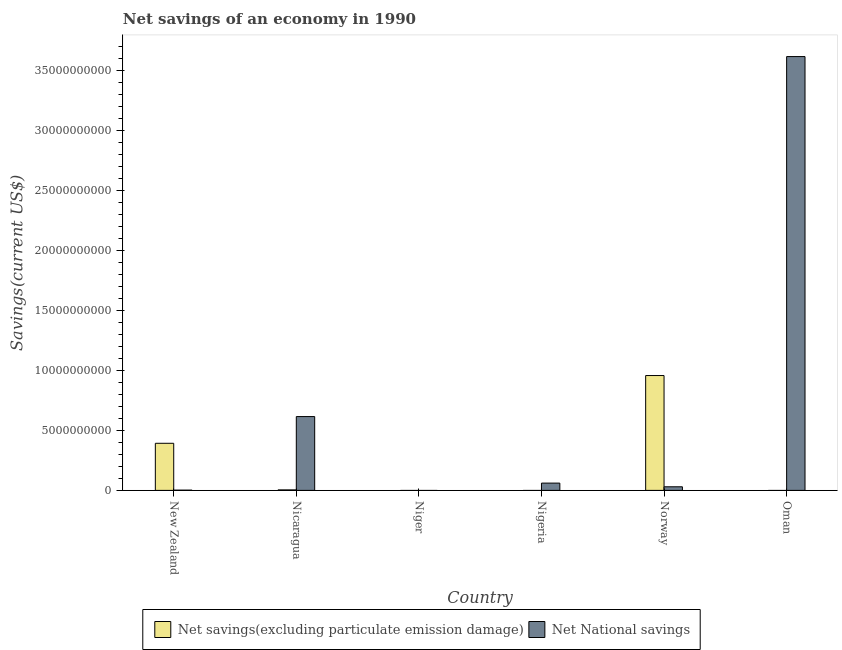Are the number of bars per tick equal to the number of legend labels?
Provide a succinct answer. No. Are the number of bars on each tick of the X-axis equal?
Keep it short and to the point. No. How many bars are there on the 2nd tick from the left?
Your answer should be compact. 2. How many bars are there on the 3rd tick from the right?
Your response must be concise. 1. What is the label of the 1st group of bars from the left?
Offer a very short reply. New Zealand. What is the net national savings in Niger?
Give a very brief answer. 0. Across all countries, what is the maximum net national savings?
Keep it short and to the point. 3.62e+1. What is the total net savings(excluding particulate emission damage) in the graph?
Offer a terse response. 1.35e+1. What is the difference between the net national savings in New Zealand and that in Oman?
Your answer should be compact. -3.62e+1. What is the difference between the net national savings in Oman and the net savings(excluding particulate emission damage) in Nigeria?
Offer a very short reply. 3.62e+1. What is the average net savings(excluding particulate emission damage) per country?
Your answer should be very brief. 2.26e+09. What is the difference between the net savings(excluding particulate emission damage) and net national savings in Norway?
Ensure brevity in your answer.  9.28e+09. What is the ratio of the net national savings in Norway to that in Oman?
Your answer should be compact. 0.01. What is the difference between the highest and the second highest net savings(excluding particulate emission damage)?
Give a very brief answer. 5.65e+09. What is the difference between the highest and the lowest net savings(excluding particulate emission damage)?
Provide a short and direct response. 9.58e+09. In how many countries, is the net savings(excluding particulate emission damage) greater than the average net savings(excluding particulate emission damage) taken over all countries?
Your answer should be very brief. 2. Is the sum of the net savings(excluding particulate emission damage) in New Zealand and Nicaragua greater than the maximum net national savings across all countries?
Provide a succinct answer. No. How many bars are there?
Give a very brief answer. 8. Are all the bars in the graph horizontal?
Your answer should be compact. No. How many countries are there in the graph?
Provide a succinct answer. 6. What is the difference between two consecutive major ticks on the Y-axis?
Provide a short and direct response. 5.00e+09. Where does the legend appear in the graph?
Provide a succinct answer. Bottom center. How are the legend labels stacked?
Your response must be concise. Horizontal. What is the title of the graph?
Make the answer very short. Net savings of an economy in 1990. What is the label or title of the Y-axis?
Your answer should be very brief. Savings(current US$). What is the Savings(current US$) of Net savings(excluding particulate emission damage) in New Zealand?
Your answer should be very brief. 3.93e+09. What is the Savings(current US$) in Net National savings in New Zealand?
Offer a terse response. 2.00e+07. What is the Savings(current US$) in Net savings(excluding particulate emission damage) in Nicaragua?
Provide a short and direct response. 4.16e+07. What is the Savings(current US$) in Net National savings in Nicaragua?
Offer a terse response. 6.15e+09. What is the Savings(current US$) in Net savings(excluding particulate emission damage) in Niger?
Your answer should be very brief. 0. What is the Savings(current US$) of Net National savings in Nigeria?
Provide a succinct answer. 6.08e+08. What is the Savings(current US$) in Net savings(excluding particulate emission damage) in Norway?
Ensure brevity in your answer.  9.58e+09. What is the Savings(current US$) in Net National savings in Norway?
Ensure brevity in your answer.  3.01e+08. What is the Savings(current US$) in Net savings(excluding particulate emission damage) in Oman?
Your answer should be compact. 0. What is the Savings(current US$) of Net National savings in Oman?
Your answer should be compact. 3.62e+1. Across all countries, what is the maximum Savings(current US$) of Net savings(excluding particulate emission damage)?
Your answer should be very brief. 9.58e+09. Across all countries, what is the maximum Savings(current US$) of Net National savings?
Ensure brevity in your answer.  3.62e+1. Across all countries, what is the minimum Savings(current US$) in Net savings(excluding particulate emission damage)?
Keep it short and to the point. 0. What is the total Savings(current US$) of Net savings(excluding particulate emission damage) in the graph?
Your response must be concise. 1.35e+1. What is the total Savings(current US$) in Net National savings in the graph?
Provide a short and direct response. 4.33e+1. What is the difference between the Savings(current US$) of Net savings(excluding particulate emission damage) in New Zealand and that in Nicaragua?
Provide a short and direct response. 3.89e+09. What is the difference between the Savings(current US$) of Net National savings in New Zealand and that in Nicaragua?
Ensure brevity in your answer.  -6.13e+09. What is the difference between the Savings(current US$) of Net National savings in New Zealand and that in Nigeria?
Make the answer very short. -5.88e+08. What is the difference between the Savings(current US$) of Net savings(excluding particulate emission damage) in New Zealand and that in Norway?
Your response must be concise. -5.65e+09. What is the difference between the Savings(current US$) of Net National savings in New Zealand and that in Norway?
Your answer should be compact. -2.81e+08. What is the difference between the Savings(current US$) of Net National savings in New Zealand and that in Oman?
Give a very brief answer. -3.62e+1. What is the difference between the Savings(current US$) of Net National savings in Nicaragua and that in Nigeria?
Keep it short and to the point. 5.55e+09. What is the difference between the Savings(current US$) in Net savings(excluding particulate emission damage) in Nicaragua and that in Norway?
Keep it short and to the point. -9.53e+09. What is the difference between the Savings(current US$) in Net National savings in Nicaragua and that in Norway?
Your response must be concise. 5.85e+09. What is the difference between the Savings(current US$) in Net National savings in Nicaragua and that in Oman?
Your answer should be very brief. -3.00e+1. What is the difference between the Savings(current US$) of Net National savings in Nigeria and that in Norway?
Your answer should be compact. 3.08e+08. What is the difference between the Savings(current US$) in Net National savings in Nigeria and that in Oman?
Provide a succinct answer. -3.56e+1. What is the difference between the Savings(current US$) in Net National savings in Norway and that in Oman?
Your answer should be very brief. -3.59e+1. What is the difference between the Savings(current US$) of Net savings(excluding particulate emission damage) in New Zealand and the Savings(current US$) of Net National savings in Nicaragua?
Your response must be concise. -2.23e+09. What is the difference between the Savings(current US$) of Net savings(excluding particulate emission damage) in New Zealand and the Savings(current US$) of Net National savings in Nigeria?
Keep it short and to the point. 3.32e+09. What is the difference between the Savings(current US$) in Net savings(excluding particulate emission damage) in New Zealand and the Savings(current US$) in Net National savings in Norway?
Offer a terse response. 3.63e+09. What is the difference between the Savings(current US$) of Net savings(excluding particulate emission damage) in New Zealand and the Savings(current US$) of Net National savings in Oman?
Ensure brevity in your answer.  -3.22e+1. What is the difference between the Savings(current US$) in Net savings(excluding particulate emission damage) in Nicaragua and the Savings(current US$) in Net National savings in Nigeria?
Your answer should be compact. -5.67e+08. What is the difference between the Savings(current US$) of Net savings(excluding particulate emission damage) in Nicaragua and the Savings(current US$) of Net National savings in Norway?
Your answer should be compact. -2.59e+08. What is the difference between the Savings(current US$) of Net savings(excluding particulate emission damage) in Nicaragua and the Savings(current US$) of Net National savings in Oman?
Provide a succinct answer. -3.61e+1. What is the difference between the Savings(current US$) of Net savings(excluding particulate emission damage) in Norway and the Savings(current US$) of Net National savings in Oman?
Provide a succinct answer. -2.66e+1. What is the average Savings(current US$) of Net savings(excluding particulate emission damage) per country?
Your response must be concise. 2.26e+09. What is the average Savings(current US$) in Net National savings per country?
Make the answer very short. 7.21e+09. What is the difference between the Savings(current US$) of Net savings(excluding particulate emission damage) and Savings(current US$) of Net National savings in New Zealand?
Provide a short and direct response. 3.91e+09. What is the difference between the Savings(current US$) of Net savings(excluding particulate emission damage) and Savings(current US$) of Net National savings in Nicaragua?
Your response must be concise. -6.11e+09. What is the difference between the Savings(current US$) of Net savings(excluding particulate emission damage) and Savings(current US$) of Net National savings in Norway?
Make the answer very short. 9.28e+09. What is the ratio of the Savings(current US$) of Net savings(excluding particulate emission damage) in New Zealand to that in Nicaragua?
Offer a terse response. 94.5. What is the ratio of the Savings(current US$) of Net National savings in New Zealand to that in Nicaragua?
Your answer should be compact. 0. What is the ratio of the Savings(current US$) in Net National savings in New Zealand to that in Nigeria?
Ensure brevity in your answer.  0.03. What is the ratio of the Savings(current US$) of Net savings(excluding particulate emission damage) in New Zealand to that in Norway?
Ensure brevity in your answer.  0.41. What is the ratio of the Savings(current US$) of Net National savings in New Zealand to that in Norway?
Provide a short and direct response. 0.07. What is the ratio of the Savings(current US$) of Net National savings in New Zealand to that in Oman?
Provide a succinct answer. 0. What is the ratio of the Savings(current US$) of Net National savings in Nicaragua to that in Nigeria?
Your answer should be compact. 10.12. What is the ratio of the Savings(current US$) in Net savings(excluding particulate emission damage) in Nicaragua to that in Norway?
Give a very brief answer. 0. What is the ratio of the Savings(current US$) of Net National savings in Nicaragua to that in Norway?
Your answer should be very brief. 20.47. What is the ratio of the Savings(current US$) of Net National savings in Nicaragua to that in Oman?
Offer a very short reply. 0.17. What is the ratio of the Savings(current US$) of Net National savings in Nigeria to that in Norway?
Give a very brief answer. 2.02. What is the ratio of the Savings(current US$) of Net National savings in Nigeria to that in Oman?
Offer a very short reply. 0.02. What is the ratio of the Savings(current US$) in Net National savings in Norway to that in Oman?
Offer a terse response. 0.01. What is the difference between the highest and the second highest Savings(current US$) of Net savings(excluding particulate emission damage)?
Keep it short and to the point. 5.65e+09. What is the difference between the highest and the second highest Savings(current US$) of Net National savings?
Provide a succinct answer. 3.00e+1. What is the difference between the highest and the lowest Savings(current US$) in Net savings(excluding particulate emission damage)?
Your answer should be compact. 9.58e+09. What is the difference between the highest and the lowest Savings(current US$) in Net National savings?
Provide a succinct answer. 3.62e+1. 